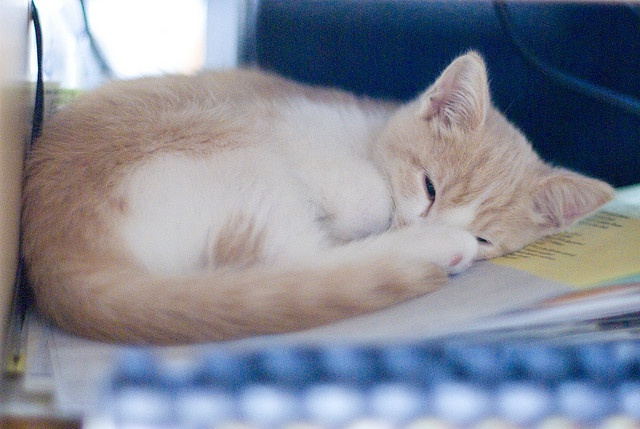Describe the objects in this image and their specific colors. I can see cat in lavender, darkgray, lightgray, and gray tones and book in lavender, darkgray, tan, and gray tones in this image. 